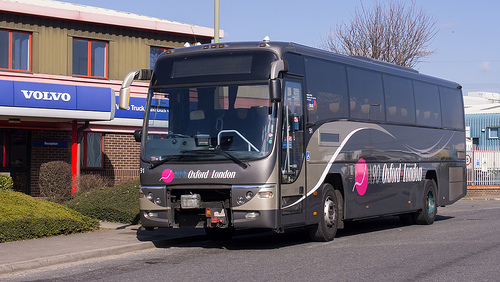Please provide a short description for this region: [0.14, 0.28, 0.24, 0.39]. The section outlines part of a window on an older stone building, showcasing worn textures and reflecting some objects from across the street. 